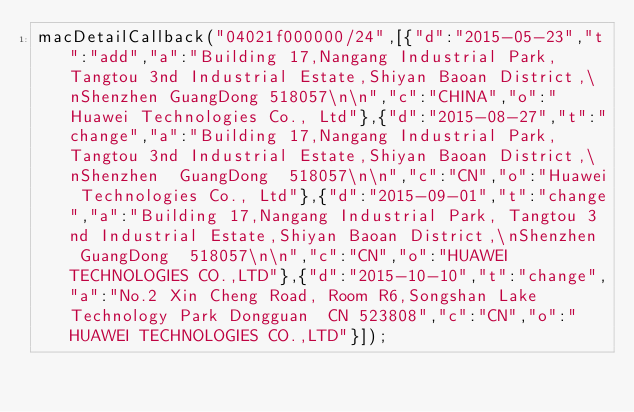<code> <loc_0><loc_0><loc_500><loc_500><_JavaScript_>macDetailCallback("04021f000000/24",[{"d":"2015-05-23","t":"add","a":"Building 17,Nangang Industrial Park, Tangtou 3nd Industrial Estate,Shiyan Baoan District,\nShenzhen GuangDong 518057\n\n","c":"CHINA","o":"Huawei Technologies Co., Ltd"},{"d":"2015-08-27","t":"change","a":"Building 17,Nangang Industrial Park, Tangtou 3nd Industrial Estate,Shiyan Baoan District,\nShenzhen  GuangDong  518057\n\n","c":"CN","o":"Huawei Technologies Co., Ltd"},{"d":"2015-09-01","t":"change","a":"Building 17,Nangang Industrial Park, Tangtou 3nd Industrial Estate,Shiyan Baoan District,\nShenzhen  GuangDong  518057\n\n","c":"CN","o":"HUAWEI TECHNOLOGIES CO.,LTD"},{"d":"2015-10-10","t":"change","a":"No.2 Xin Cheng Road, Room R6,Songshan Lake Technology Park Dongguan  CN 523808","c":"CN","o":"HUAWEI TECHNOLOGIES CO.,LTD"}]);
</code> 